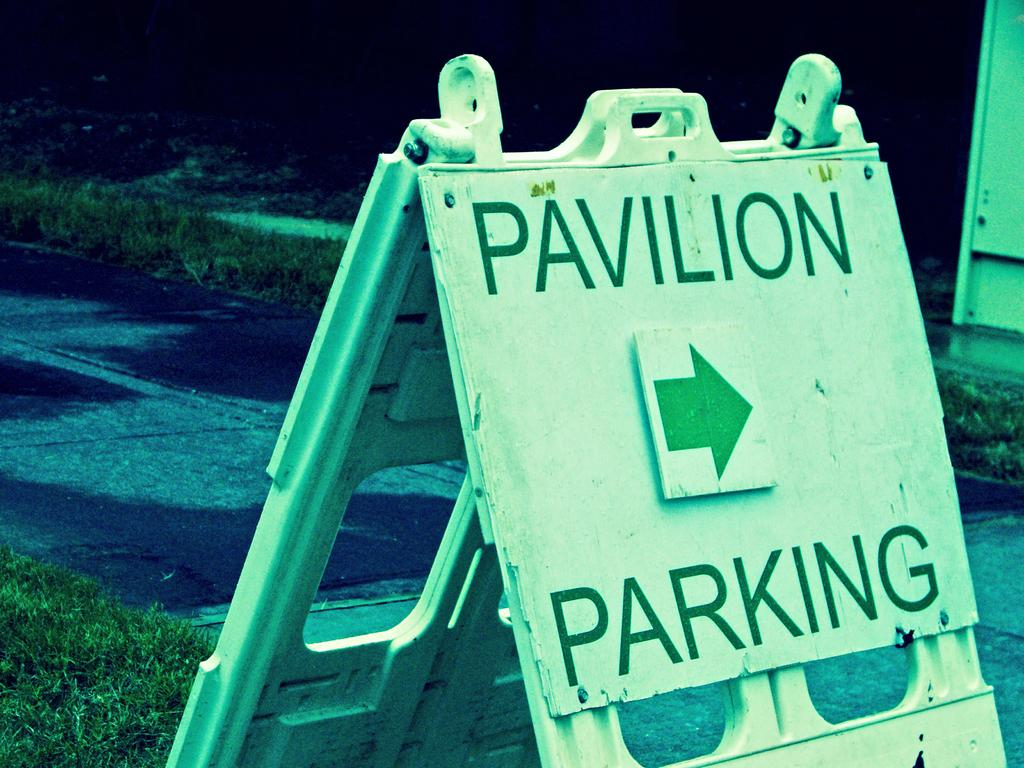What is the main object in the image? There is a board attached to a stand in the image. What is written on the board? The board has "pavilion parking" written on it. What can be seen in the background of the image? There is greenery and the ground visible in the background of the image. What type of cheese is being used to light the lamp in the image? There is no lamp or cheese present in the image. 